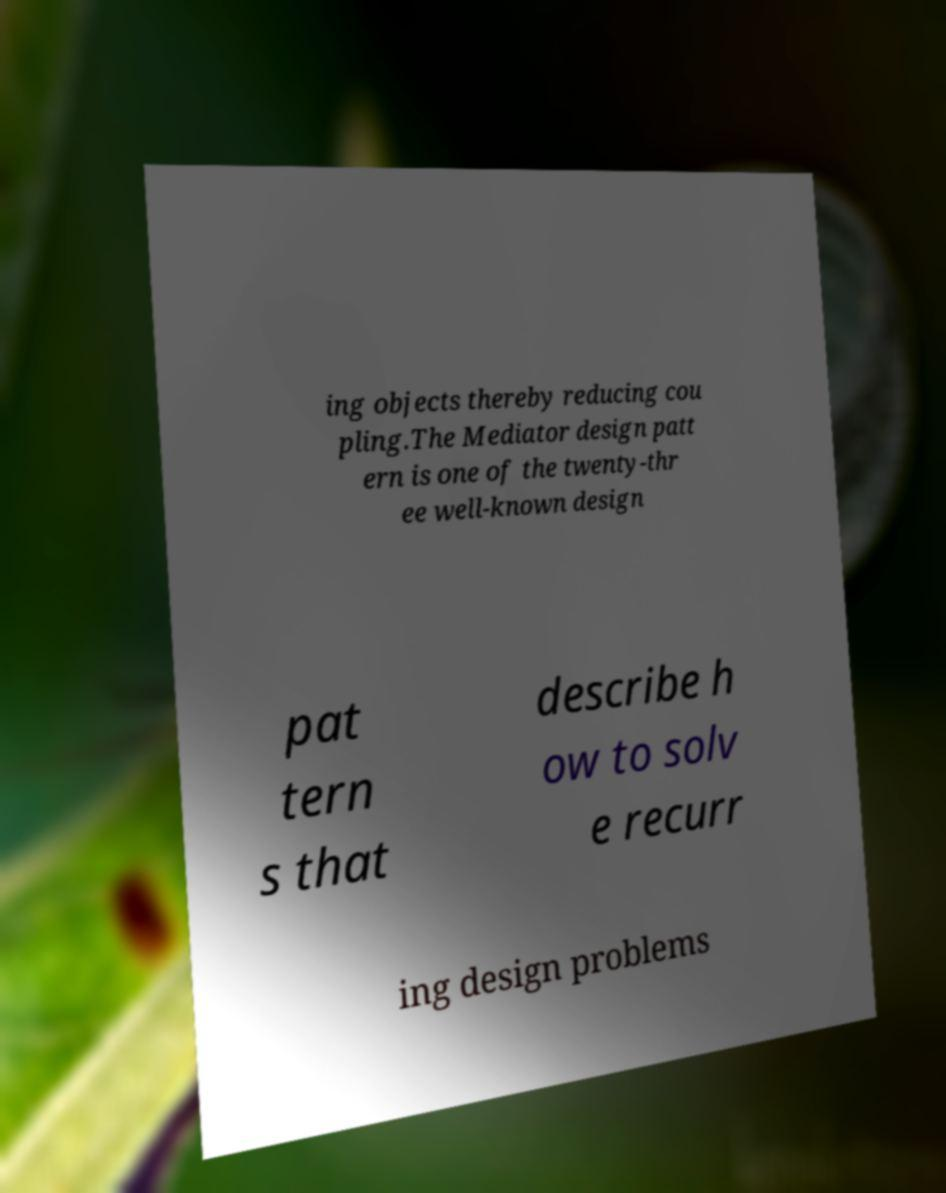I need the written content from this picture converted into text. Can you do that? ing objects thereby reducing cou pling.The Mediator design patt ern is one of the twenty-thr ee well-known design pat tern s that describe h ow to solv e recurr ing design problems 